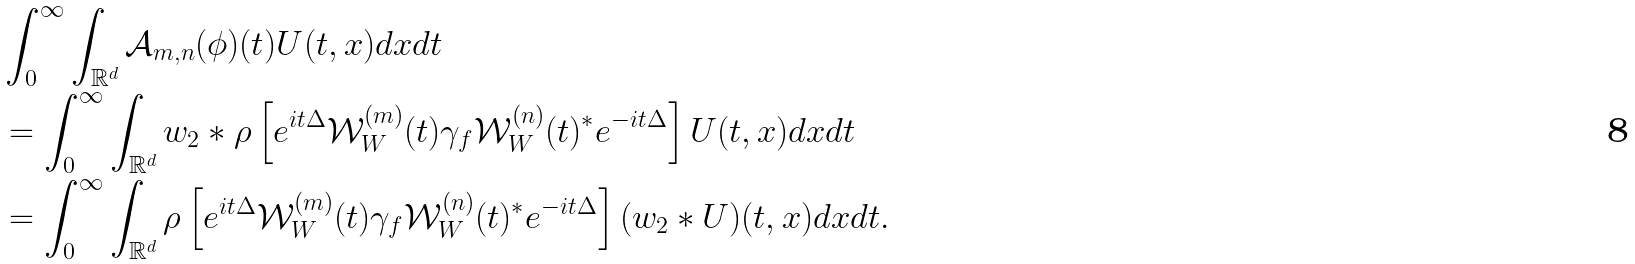<formula> <loc_0><loc_0><loc_500><loc_500>& \int _ { 0 } ^ { \infty } \int _ { \mathbb { R } ^ { d } } \mathcal { A } _ { m , n } ( \phi ) ( t ) U ( t , x ) d x d t \\ & = \int _ { 0 } ^ { \infty } \int _ { \mathbb { R } ^ { d } } w _ { 2 } * \rho \left [ e ^ { i t \Delta } \mathcal { W } _ { W } ^ { ( m ) } ( t ) \gamma _ { f } \mathcal { W } _ { W } ^ { ( n ) } ( t ) ^ { * } e ^ { - i t \Delta } \right ] U ( t , x ) d x d t \\ & = \int _ { 0 } ^ { \infty } \int _ { \mathbb { R } ^ { d } } \rho \left [ e ^ { i t \Delta } \mathcal { W } _ { W } ^ { ( m ) } ( t ) \gamma _ { f } \mathcal { W } _ { W } ^ { ( n ) } ( t ) ^ { * } e ^ { - i t \Delta } \right ] ( w _ { 2 } * U ) ( t , x ) d x d t .</formula> 